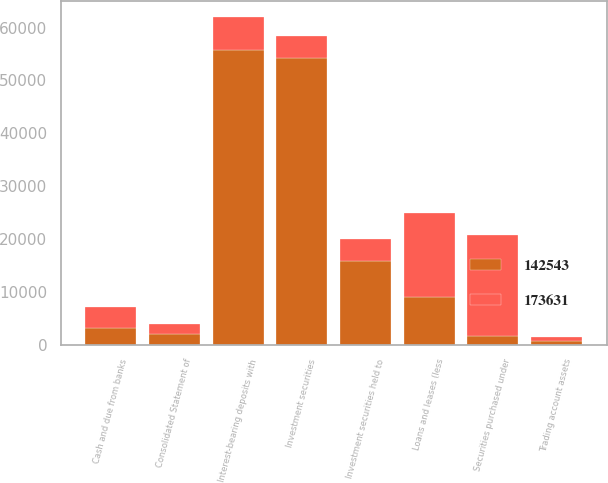Convert chart. <chart><loc_0><loc_0><loc_500><loc_500><stacked_bar_chart><ecel><fcel>Consolidated Statement of<fcel>Cash and due from banks<fcel>Interest-bearing deposits with<fcel>Securities purchased under<fcel>Trading account assets<fcel>Investment securities<fcel>Investment securities held to<fcel>Loans and leases (less<nl><fcel>142543<fcel>2008<fcel>3181<fcel>55733<fcel>1635<fcel>815<fcel>54163<fcel>15767<fcel>9113<nl><fcel>173631<fcel>2007<fcel>4041<fcel>6271<fcel>19133<fcel>589<fcel>4233<fcel>4233<fcel>15784<nl></chart> 